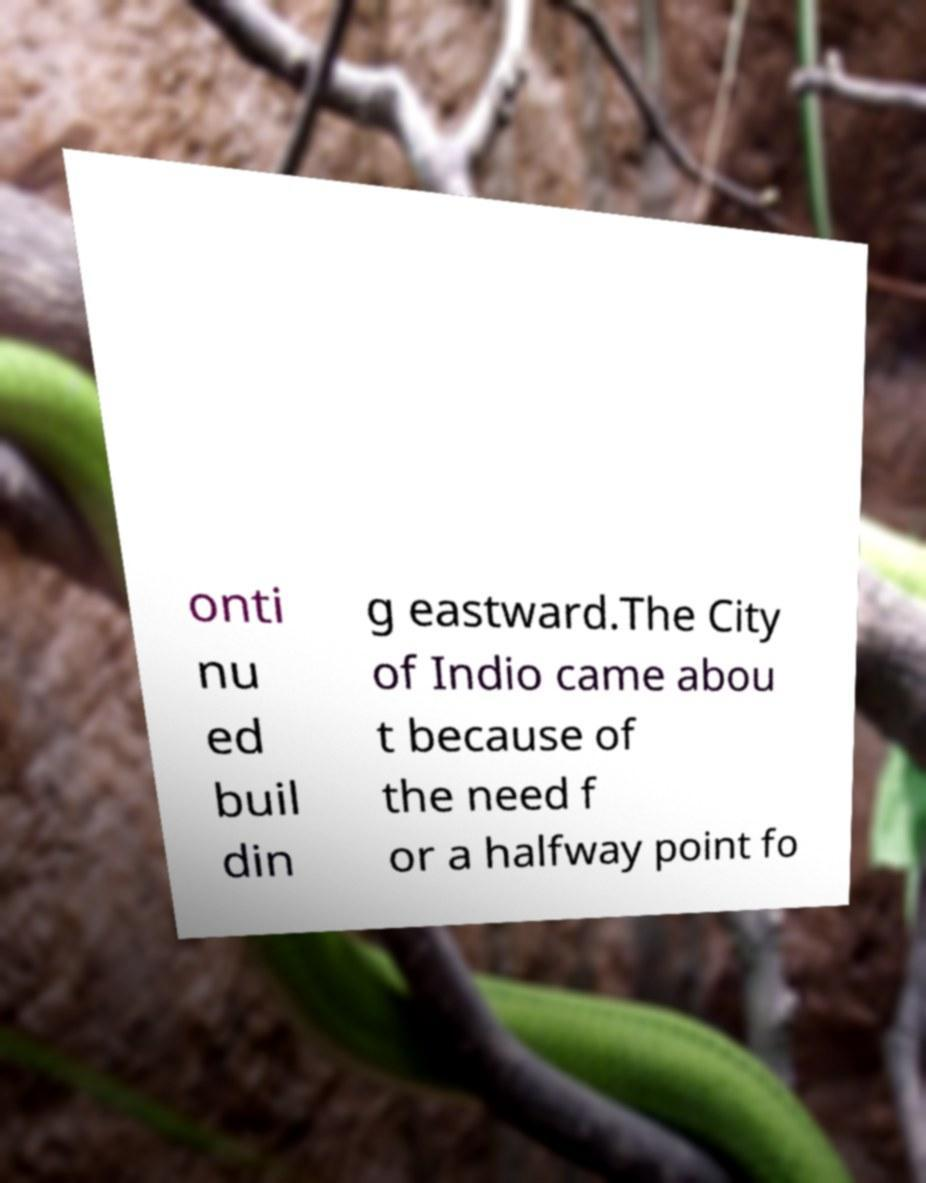Please identify and transcribe the text found in this image. onti nu ed buil din g eastward.The City of Indio came abou t because of the need f or a halfway point fo 